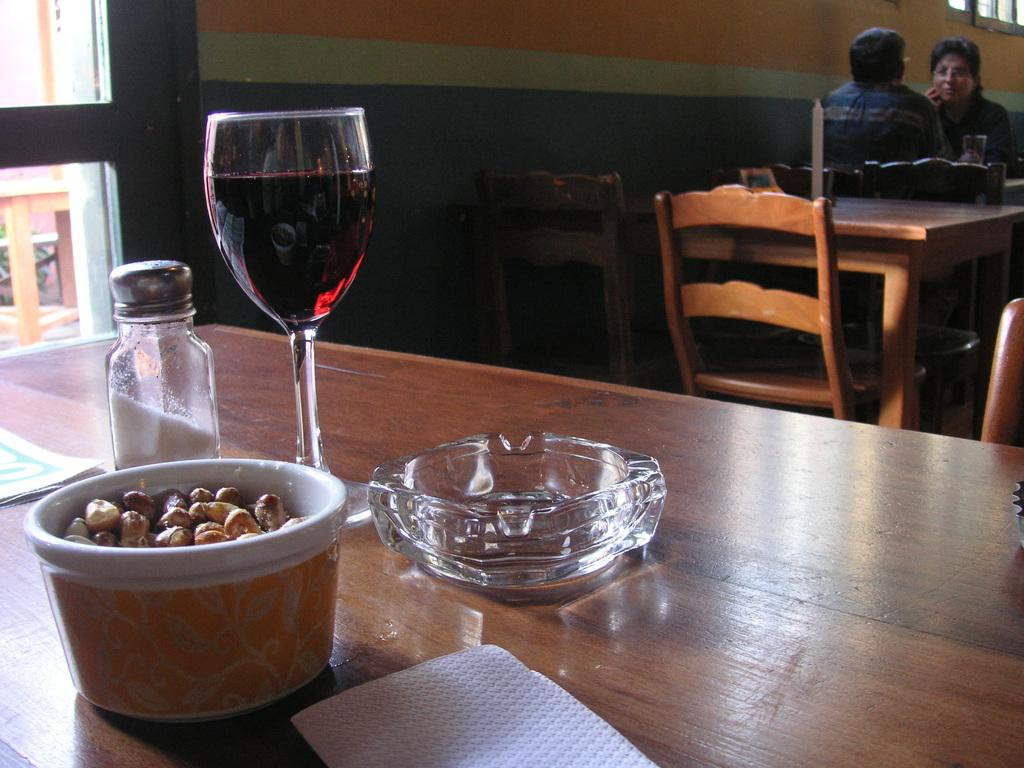What type of glass can be seen in the image? There is a wine glass in the image. What type of container is present for seasoning? There is a salt jar in the image. What is in the bowl that is visible in the image? There is a bowl of food in the image. What item might be used for cleaning or wiping in the image? There is a tissue in the image. What type of dish is present in the image? There is a glass plate in the image. Can you describe the people in the background of the image? There are two persons sitting in chairs in the background of the image. What type of meat is being destroyed in the image? There is no meat or destruction present in the image. What type of vase is holding the flowers in the image? There are no flowers or vases present in the image. 